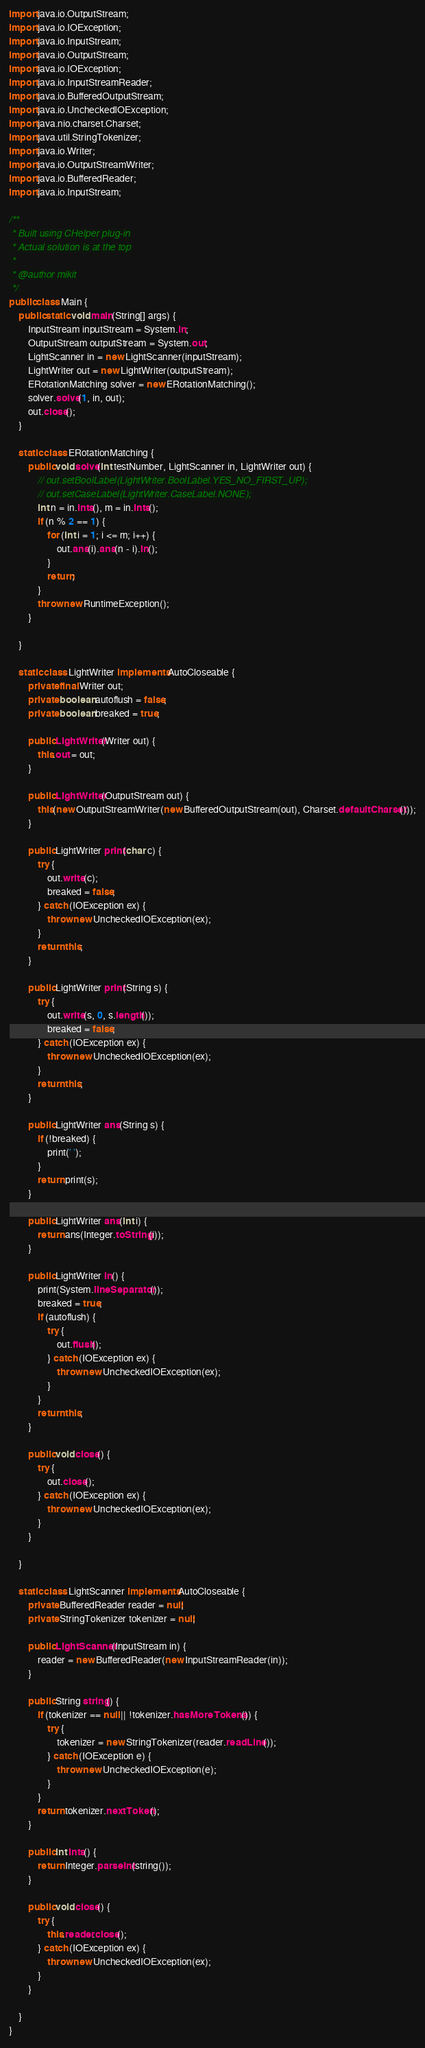<code> <loc_0><loc_0><loc_500><loc_500><_Java_>import java.io.OutputStream;
import java.io.IOException;
import java.io.InputStream;
import java.io.OutputStream;
import java.io.IOException;
import java.io.InputStreamReader;
import java.io.BufferedOutputStream;
import java.io.UncheckedIOException;
import java.nio.charset.Charset;
import java.util.StringTokenizer;
import java.io.Writer;
import java.io.OutputStreamWriter;
import java.io.BufferedReader;
import java.io.InputStream;

/**
 * Built using CHelper plug-in
 * Actual solution is at the top
 *
 * @author mikit
 */
public class Main {
    public static void main(String[] args) {
        InputStream inputStream = System.in;
        OutputStream outputStream = System.out;
        LightScanner in = new LightScanner(inputStream);
        LightWriter out = new LightWriter(outputStream);
        ERotationMatching solver = new ERotationMatching();
        solver.solve(1, in, out);
        out.close();
    }

    static class ERotationMatching {
        public void solve(int testNumber, LightScanner in, LightWriter out) {
            // out.setBoolLabel(LightWriter.BoolLabel.YES_NO_FIRST_UP);
            // out.setCaseLabel(LightWriter.CaseLabel.NONE);
            int n = in.ints(), m = in.ints();
            if (n % 2 == 1) {
                for (int i = 1; i <= m; i++) {
                    out.ans(i).ans(n - i).ln();
                }
                return;
            }
            throw new RuntimeException();
        }

    }

    static class LightWriter implements AutoCloseable {
        private final Writer out;
        private boolean autoflush = false;
        private boolean breaked = true;

        public LightWriter(Writer out) {
            this.out = out;
        }

        public LightWriter(OutputStream out) {
            this(new OutputStreamWriter(new BufferedOutputStream(out), Charset.defaultCharset()));
        }

        public LightWriter print(char c) {
            try {
                out.write(c);
                breaked = false;
            } catch (IOException ex) {
                throw new UncheckedIOException(ex);
            }
            return this;
        }

        public LightWriter print(String s) {
            try {
                out.write(s, 0, s.length());
                breaked = false;
            } catch (IOException ex) {
                throw new UncheckedIOException(ex);
            }
            return this;
        }

        public LightWriter ans(String s) {
            if (!breaked) {
                print(' ');
            }
            return print(s);
        }

        public LightWriter ans(int i) {
            return ans(Integer.toString(i));
        }

        public LightWriter ln() {
            print(System.lineSeparator());
            breaked = true;
            if (autoflush) {
                try {
                    out.flush();
                } catch (IOException ex) {
                    throw new UncheckedIOException(ex);
                }
            }
            return this;
        }

        public void close() {
            try {
                out.close();
            } catch (IOException ex) {
                throw new UncheckedIOException(ex);
            }
        }

    }

    static class LightScanner implements AutoCloseable {
        private BufferedReader reader = null;
        private StringTokenizer tokenizer = null;

        public LightScanner(InputStream in) {
            reader = new BufferedReader(new InputStreamReader(in));
        }

        public String string() {
            if (tokenizer == null || !tokenizer.hasMoreTokens()) {
                try {
                    tokenizer = new StringTokenizer(reader.readLine());
                } catch (IOException e) {
                    throw new UncheckedIOException(e);
                }
            }
            return tokenizer.nextToken();
        }

        public int ints() {
            return Integer.parseInt(string());
        }

        public void close() {
            try {
                this.reader.close();
            } catch (IOException ex) {
                throw new UncheckedIOException(ex);
            }
        }

    }
}

</code> 